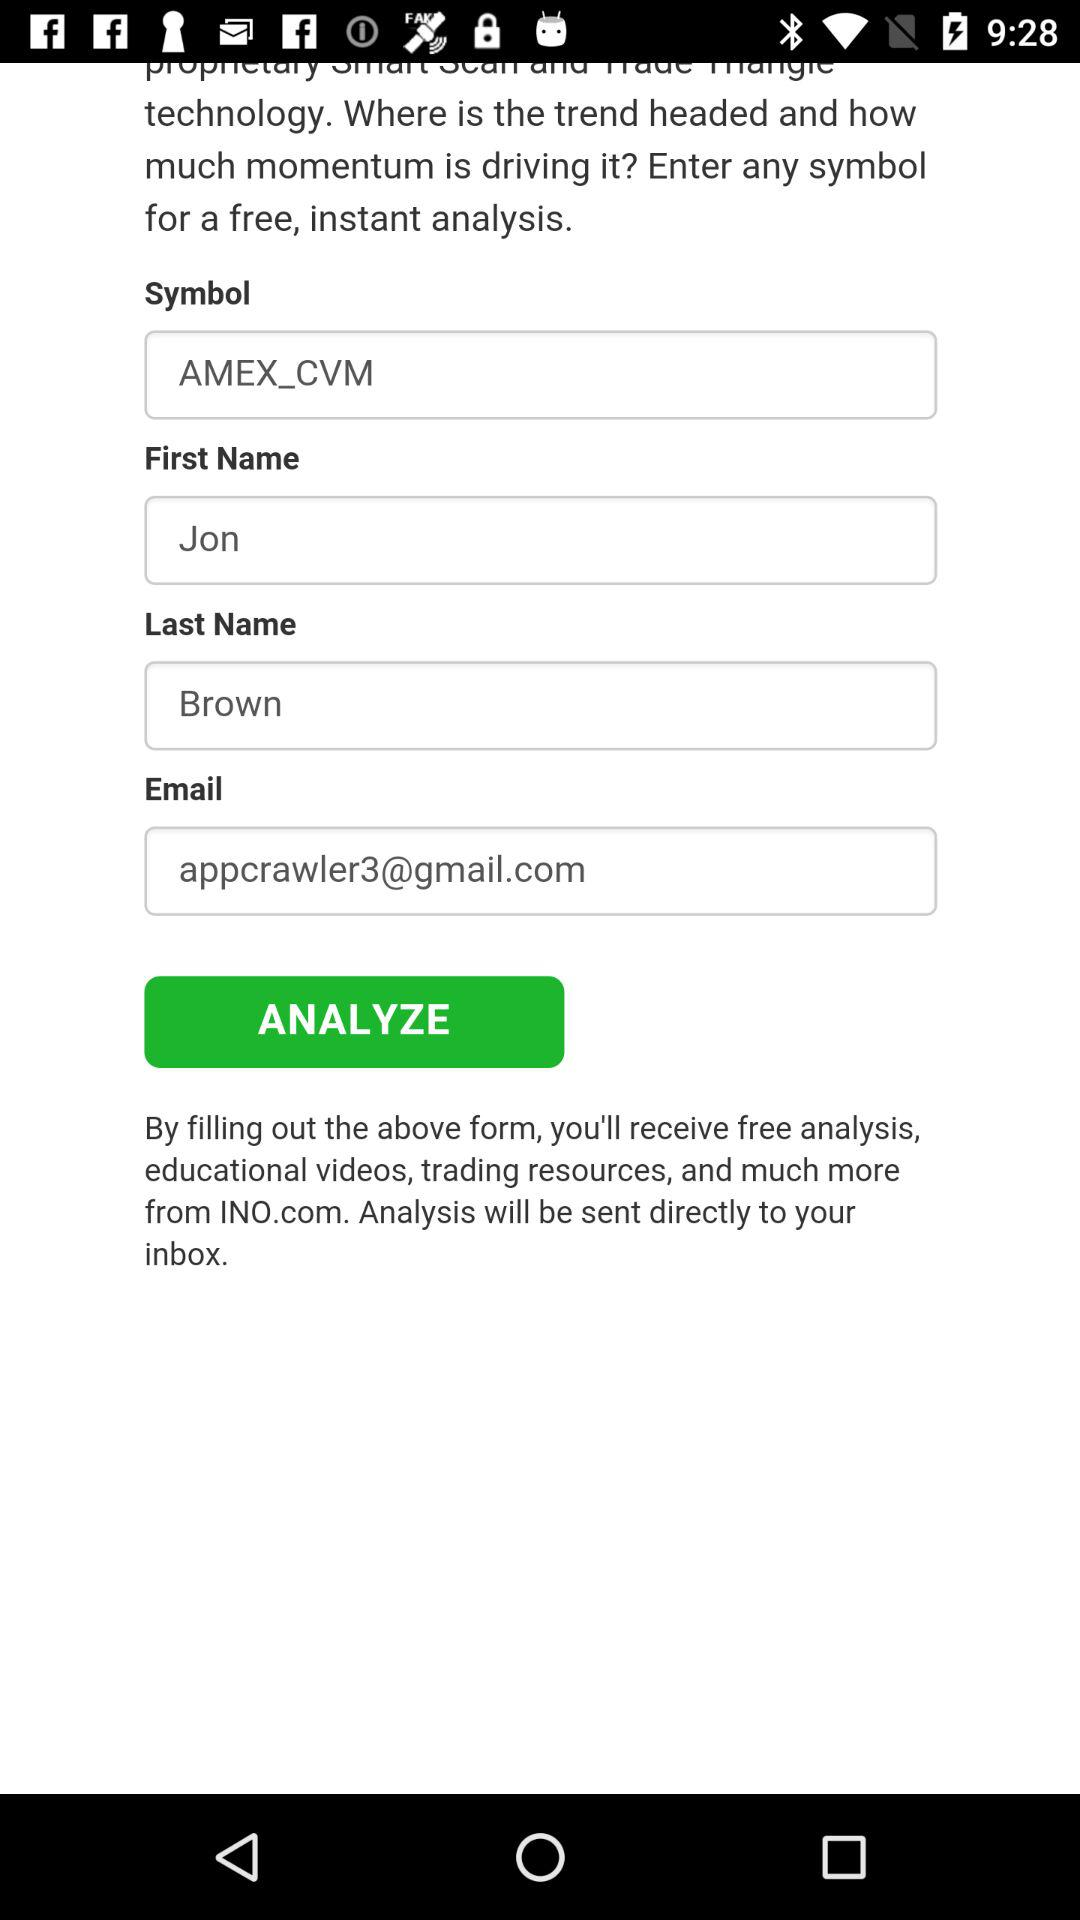What is the last name of the user? The last name of the user is Brown. 